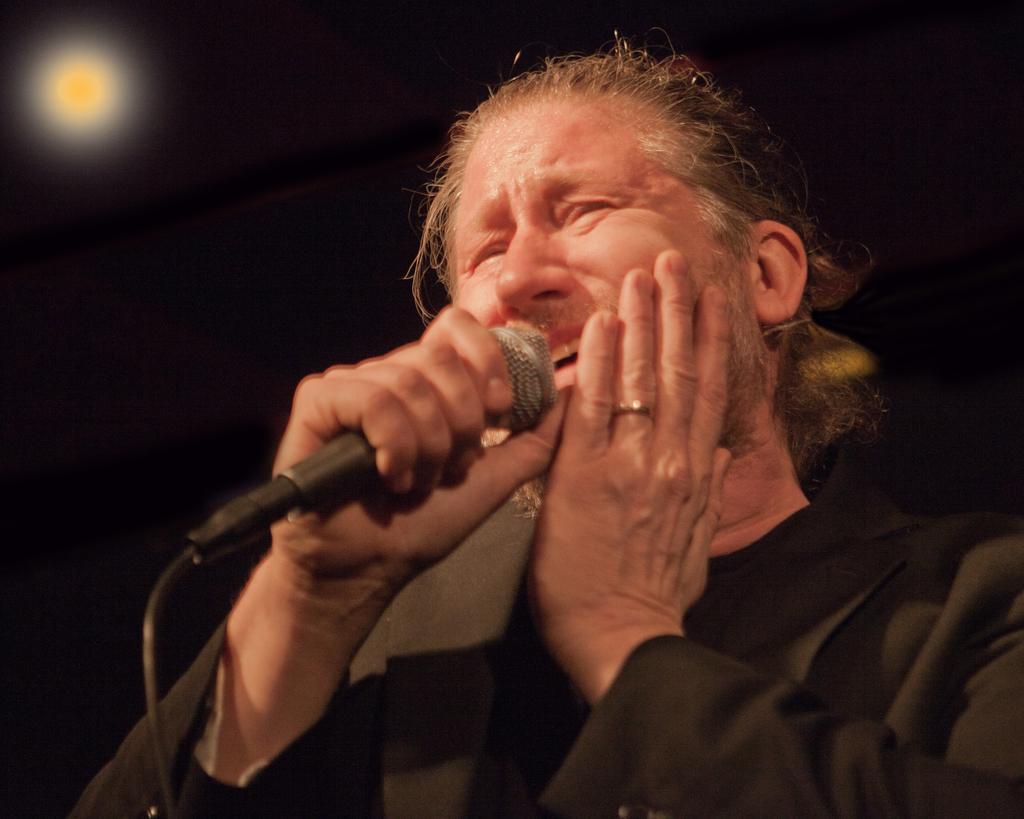Please provide a concise description of this image. In this image we can see a man holding a mic and it looks like he is singing and in the background the image is dark and we can see a light which looks like the moon. 